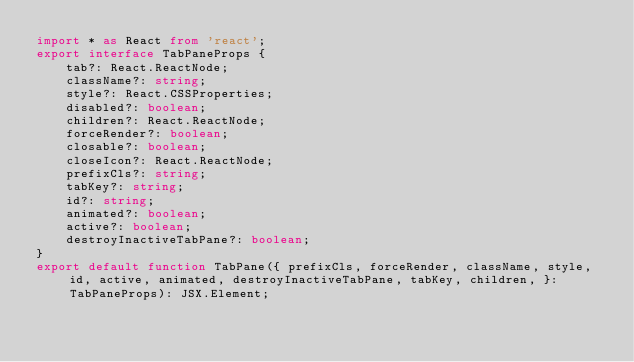<code> <loc_0><loc_0><loc_500><loc_500><_TypeScript_>import * as React from 'react';
export interface TabPaneProps {
    tab?: React.ReactNode;
    className?: string;
    style?: React.CSSProperties;
    disabled?: boolean;
    children?: React.ReactNode;
    forceRender?: boolean;
    closable?: boolean;
    closeIcon?: React.ReactNode;
    prefixCls?: string;
    tabKey?: string;
    id?: string;
    animated?: boolean;
    active?: boolean;
    destroyInactiveTabPane?: boolean;
}
export default function TabPane({ prefixCls, forceRender, className, style, id, active, animated, destroyInactiveTabPane, tabKey, children, }: TabPaneProps): JSX.Element;
</code> 